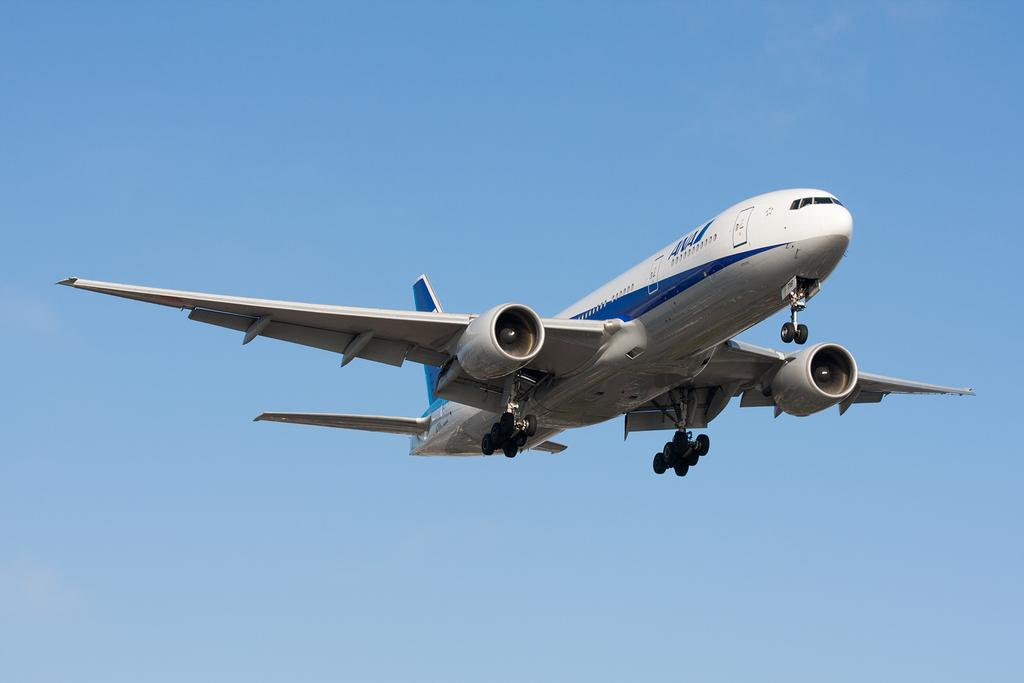What is the main subject of the image? The main subject of the image is a plane. What is the plane doing in the image? The plane is flying in the air. What can be seen in the background of the image? The sky is visible in the image. Are there any weather conditions depicted in the image? Yes, clouds are present in the image. What type of statement can be seen written on the plane in the image? There is no statement visible on the plane in the image. Can you tell me how many marbles are present on the plane in the image? There are no marbles present on the plane in the image. 